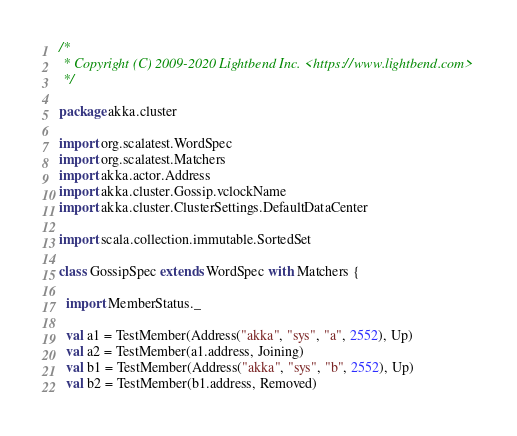Convert code to text. <code><loc_0><loc_0><loc_500><loc_500><_Scala_>/*
 * Copyright (C) 2009-2020 Lightbend Inc. <https://www.lightbend.com>
 */

package akka.cluster

import org.scalatest.WordSpec
import org.scalatest.Matchers
import akka.actor.Address
import akka.cluster.Gossip.vclockName
import akka.cluster.ClusterSettings.DefaultDataCenter

import scala.collection.immutable.SortedSet

class GossipSpec extends WordSpec with Matchers {

  import MemberStatus._

  val a1 = TestMember(Address("akka", "sys", "a", 2552), Up)
  val a2 = TestMember(a1.address, Joining)
  val b1 = TestMember(Address("akka", "sys", "b", 2552), Up)
  val b2 = TestMember(b1.address, Removed)</code> 